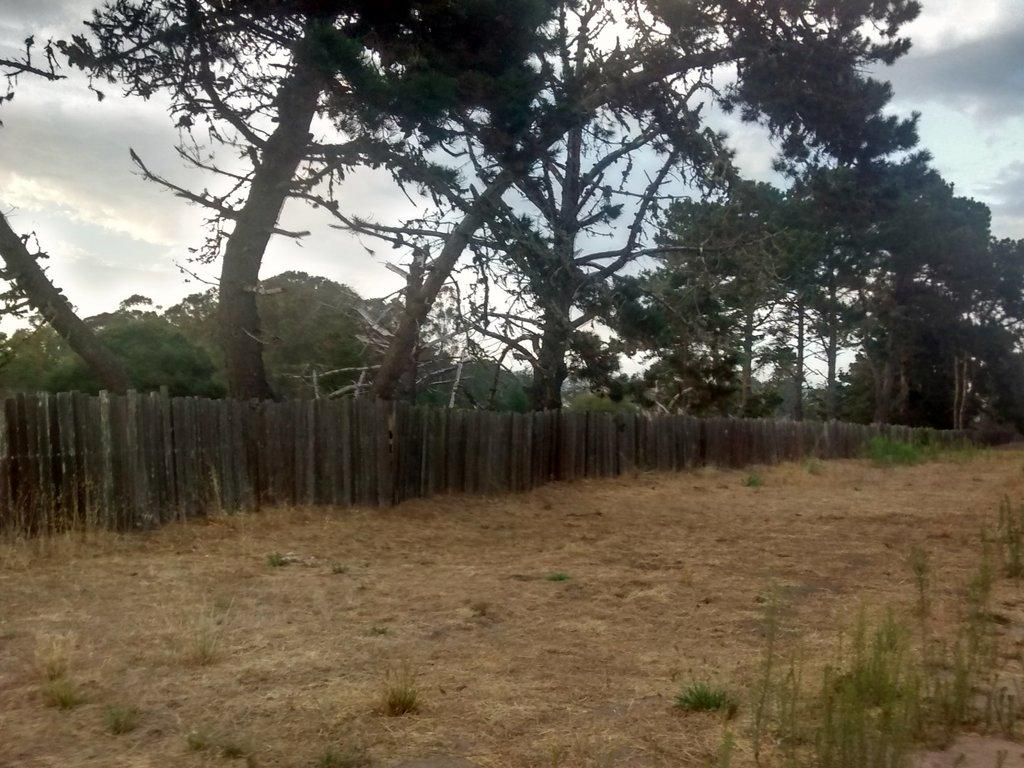What type of vegetation is at the bottom of the picture? There is grass at the bottom of the picture. What is located beside the grass? There is a wooden fence beside the grass. What can be seen in the background of the image? There are trees in the background of the image. What is visible at the top of the picture? The sky is visible at the top of the picture. Can you tell me how many rifles are leaning against the wooden fence in the image? There are no rifles present in the image; it features grass, a wooden fence, trees, and the sky. What type of prose is being written on the grass in the image? There is no prose or writing present on the grass in the image. 